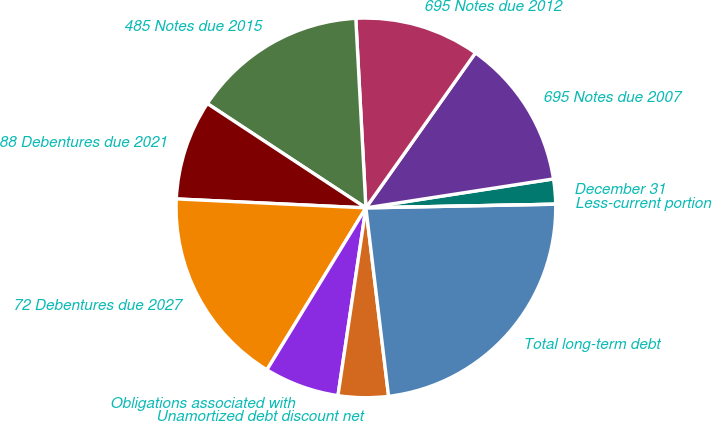Convert chart to OTSL. <chart><loc_0><loc_0><loc_500><loc_500><pie_chart><fcel>December 31<fcel>695 Notes due 2007<fcel>695 Notes due 2012<fcel>485 Notes due 2015<fcel>88 Debentures due 2021<fcel>72 Debentures due 2027<fcel>Obligations associated with<fcel>Unamortized debt discount net<fcel>Total long-term debt<fcel>Less-current portion<nl><fcel>2.13%<fcel>12.77%<fcel>10.64%<fcel>14.89%<fcel>8.51%<fcel>17.02%<fcel>6.38%<fcel>4.26%<fcel>23.4%<fcel>0.0%<nl></chart> 